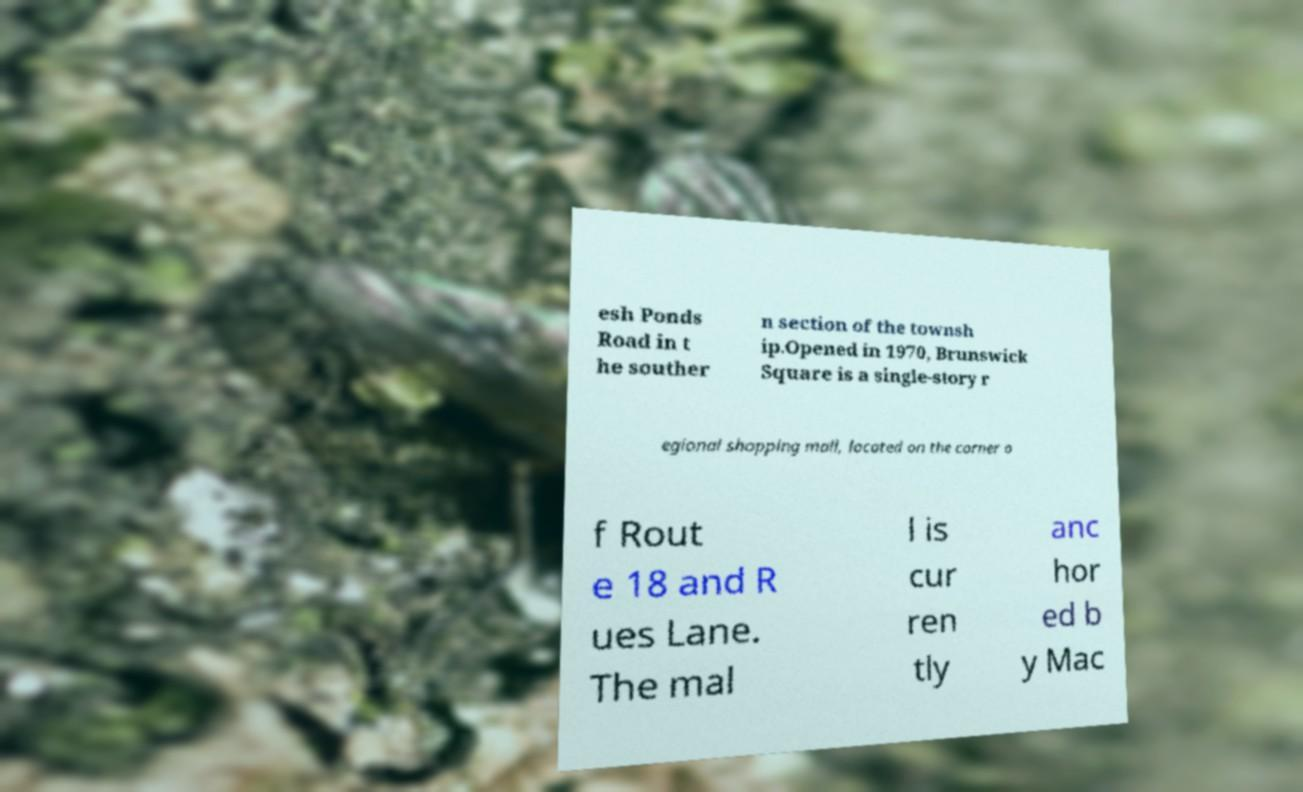There's text embedded in this image that I need extracted. Can you transcribe it verbatim? esh Ponds Road in t he souther n section of the townsh ip.Opened in 1970, Brunswick Square is a single-story r egional shopping mall, located on the corner o f Rout e 18 and R ues Lane. The mal l is cur ren tly anc hor ed b y Mac 